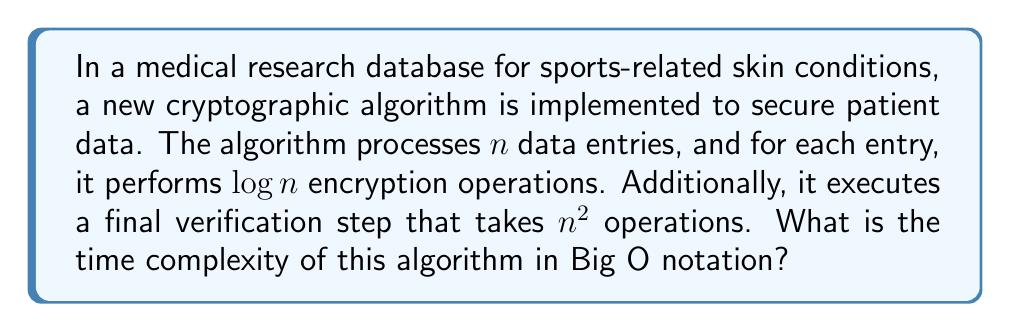Can you answer this question? To determine the time complexity of this algorithm, we need to analyze its components:

1. Data Entry Processing:
   - The algorithm processes $n$ data entries.
   - For each entry, it performs $\log n$ encryption operations.
   - Total operations for this step: $n \cdot \log n$

2. Final Verification Step:
   - This step takes $n^2$ operations.

3. Combining the steps:
   - Total operations = $(n \cdot \log n) + n^2$

4. Applying Big O notation rules:
   - We keep the term with the highest growth rate.
   - $n^2$ grows faster than $n \log n$ for large $n$.

5. Therefore, the dominant term is $n^2$.

In Big O notation, we express this as $O(n^2)$, which represents the upper bound of the algorithm's time complexity.
Answer: $O(n^2)$ 